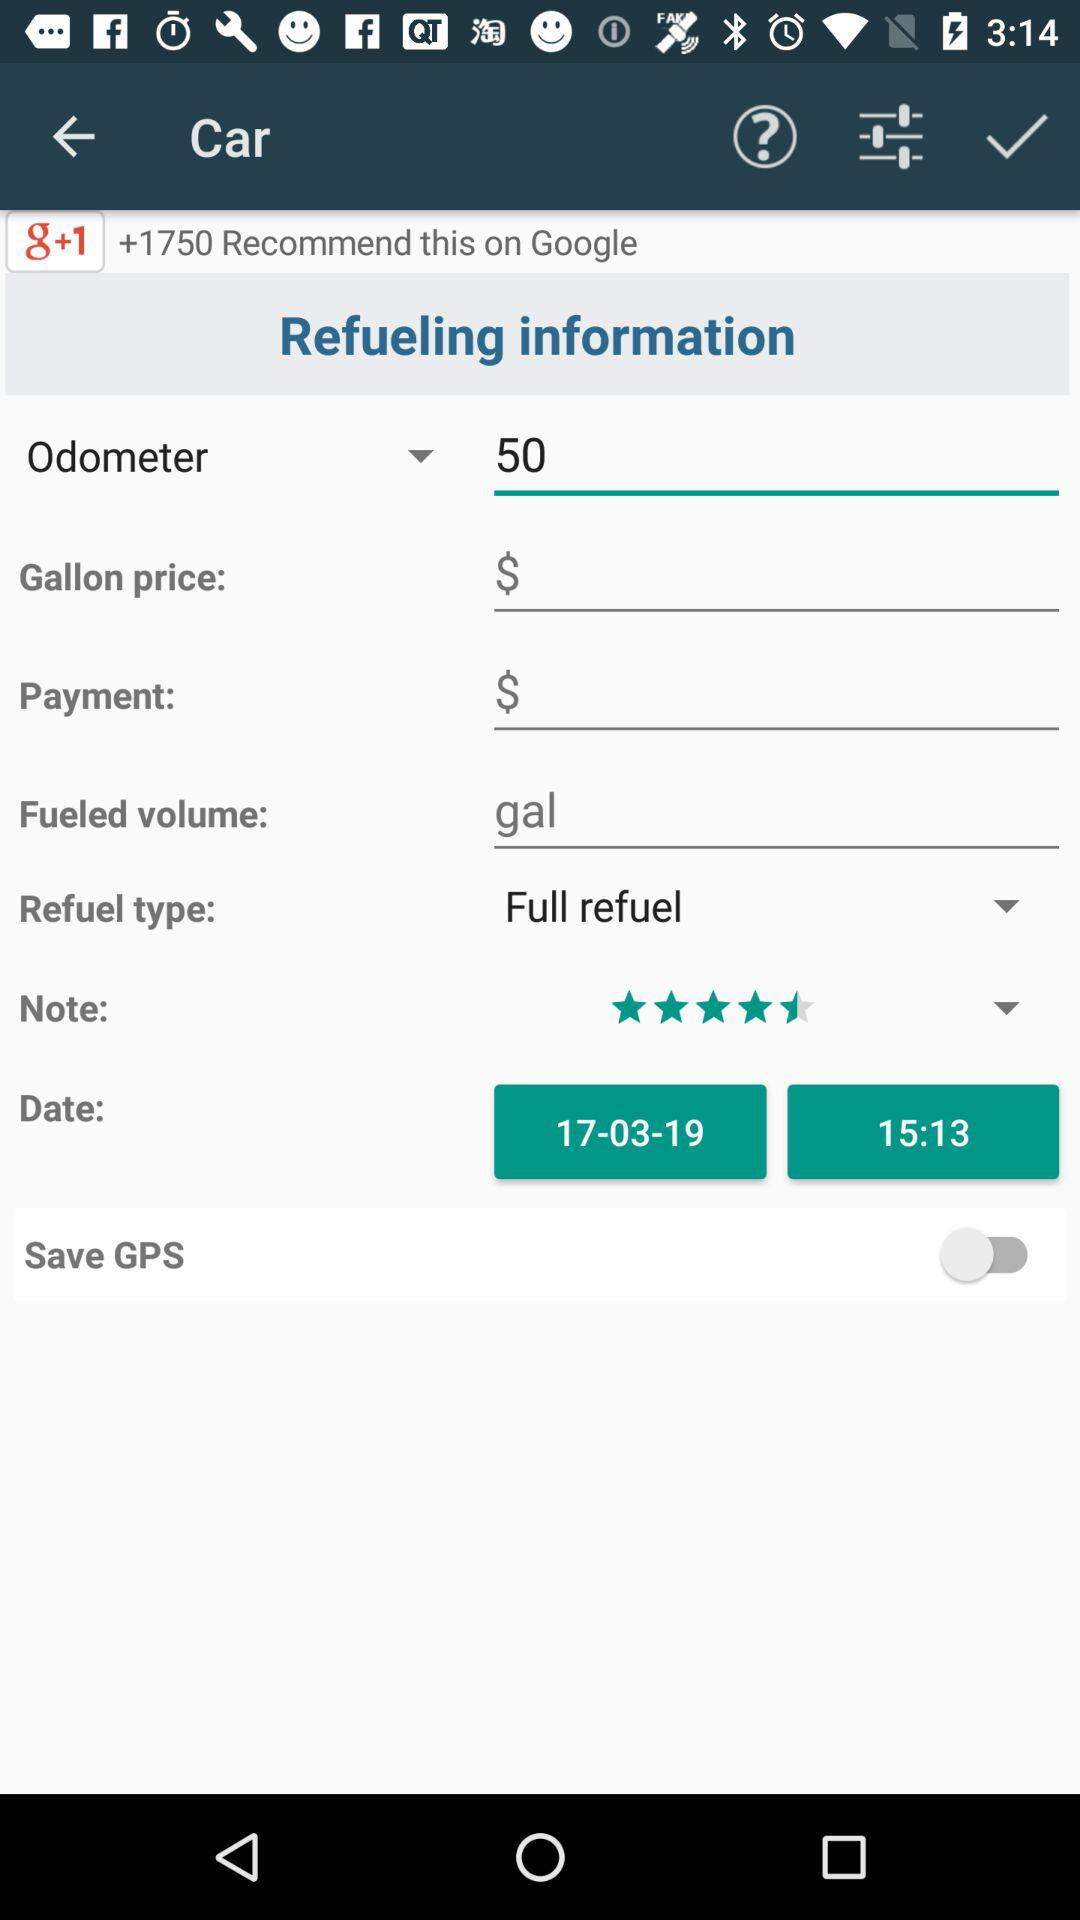What is the odometer value? The odometer value is 50. 